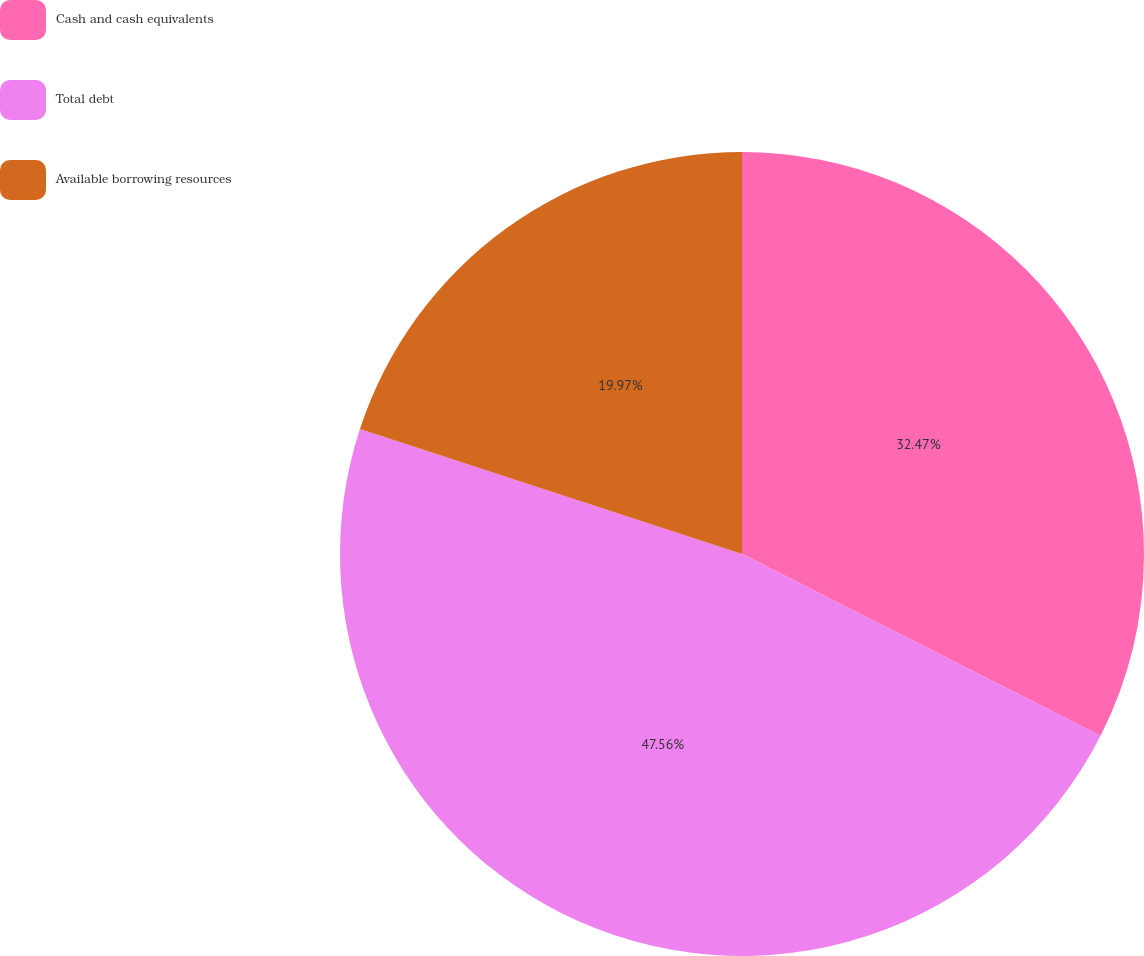<chart> <loc_0><loc_0><loc_500><loc_500><pie_chart><fcel>Cash and cash equivalents<fcel>Total debt<fcel>Available borrowing resources<nl><fcel>32.47%<fcel>47.56%<fcel>19.97%<nl></chart> 